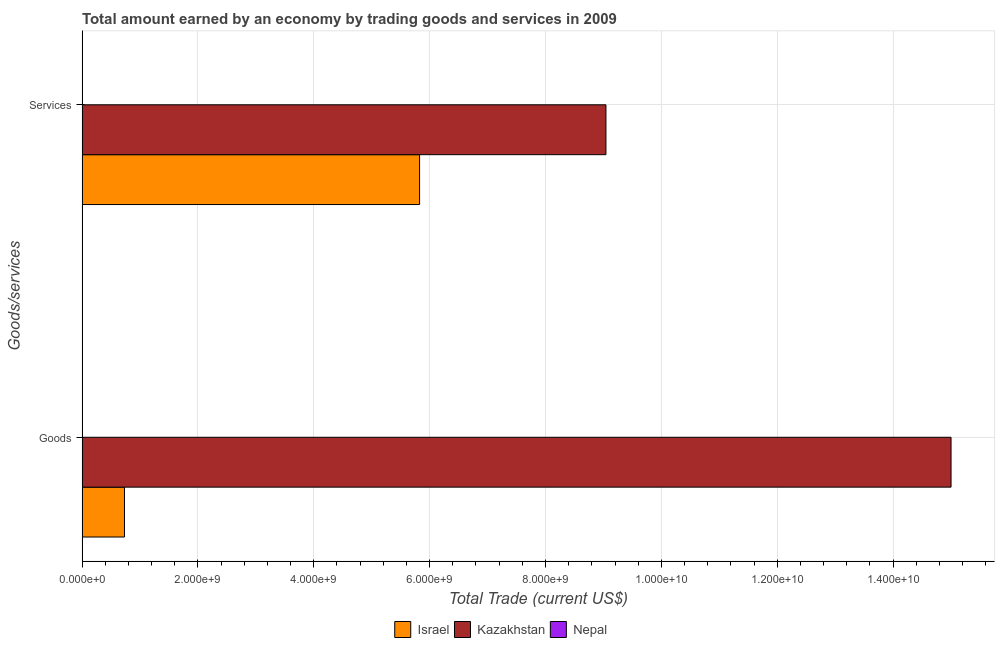How many different coloured bars are there?
Keep it short and to the point. 2. How many groups of bars are there?
Provide a succinct answer. 2. How many bars are there on the 2nd tick from the top?
Your answer should be very brief. 2. How many bars are there on the 2nd tick from the bottom?
Your answer should be compact. 2. What is the label of the 1st group of bars from the top?
Make the answer very short. Services. What is the amount earned by trading goods in Kazakhstan?
Make the answer very short. 1.50e+1. Across all countries, what is the maximum amount earned by trading services?
Provide a succinct answer. 9.04e+09. Across all countries, what is the minimum amount earned by trading services?
Provide a succinct answer. 0. In which country was the amount earned by trading services maximum?
Your answer should be very brief. Kazakhstan. What is the total amount earned by trading services in the graph?
Provide a succinct answer. 1.49e+1. What is the difference between the amount earned by trading services in Kazakhstan and that in Israel?
Keep it short and to the point. 3.22e+09. What is the difference between the amount earned by trading goods in Israel and the amount earned by trading services in Kazakhstan?
Offer a very short reply. -8.31e+09. What is the average amount earned by trading services per country?
Keep it short and to the point. 4.96e+09. What is the difference between the amount earned by trading services and amount earned by trading goods in Kazakhstan?
Provide a succinct answer. -5.96e+09. In how many countries, is the amount earned by trading goods greater than 3600000000 US$?
Ensure brevity in your answer.  1. What is the ratio of the amount earned by trading services in Kazakhstan to that in Israel?
Keep it short and to the point. 1.55. In how many countries, is the amount earned by trading goods greater than the average amount earned by trading goods taken over all countries?
Offer a very short reply. 1. How many countries are there in the graph?
Your answer should be very brief. 3. What is the difference between two consecutive major ticks on the X-axis?
Ensure brevity in your answer.  2.00e+09. Are the values on the major ticks of X-axis written in scientific E-notation?
Offer a terse response. Yes. Does the graph contain any zero values?
Make the answer very short. Yes. Where does the legend appear in the graph?
Keep it short and to the point. Bottom center. How are the legend labels stacked?
Offer a terse response. Horizontal. What is the title of the graph?
Keep it short and to the point. Total amount earned by an economy by trading goods and services in 2009. Does "Czech Republic" appear as one of the legend labels in the graph?
Provide a succinct answer. No. What is the label or title of the X-axis?
Offer a very short reply. Total Trade (current US$). What is the label or title of the Y-axis?
Your answer should be compact. Goods/services. What is the Total Trade (current US$) of Israel in Goods?
Ensure brevity in your answer.  7.33e+08. What is the Total Trade (current US$) in Kazakhstan in Goods?
Ensure brevity in your answer.  1.50e+1. What is the Total Trade (current US$) of Nepal in Goods?
Offer a very short reply. 0. What is the Total Trade (current US$) in Israel in Services?
Your answer should be compact. 5.83e+09. What is the Total Trade (current US$) of Kazakhstan in Services?
Your response must be concise. 9.04e+09. What is the Total Trade (current US$) of Nepal in Services?
Make the answer very short. 0. Across all Goods/services, what is the maximum Total Trade (current US$) of Israel?
Make the answer very short. 5.83e+09. Across all Goods/services, what is the maximum Total Trade (current US$) of Kazakhstan?
Ensure brevity in your answer.  1.50e+1. Across all Goods/services, what is the minimum Total Trade (current US$) in Israel?
Provide a succinct answer. 7.33e+08. Across all Goods/services, what is the minimum Total Trade (current US$) of Kazakhstan?
Provide a short and direct response. 9.04e+09. What is the total Total Trade (current US$) of Israel in the graph?
Offer a terse response. 6.56e+09. What is the total Total Trade (current US$) in Kazakhstan in the graph?
Keep it short and to the point. 2.40e+1. What is the total Total Trade (current US$) in Nepal in the graph?
Make the answer very short. 0. What is the difference between the Total Trade (current US$) of Israel in Goods and that in Services?
Make the answer very short. -5.09e+09. What is the difference between the Total Trade (current US$) of Kazakhstan in Goods and that in Services?
Your answer should be compact. 5.96e+09. What is the difference between the Total Trade (current US$) of Israel in Goods and the Total Trade (current US$) of Kazakhstan in Services?
Make the answer very short. -8.31e+09. What is the average Total Trade (current US$) in Israel per Goods/services?
Keep it short and to the point. 3.28e+09. What is the average Total Trade (current US$) in Kazakhstan per Goods/services?
Give a very brief answer. 1.20e+1. What is the difference between the Total Trade (current US$) in Israel and Total Trade (current US$) in Kazakhstan in Goods?
Your answer should be compact. -1.43e+1. What is the difference between the Total Trade (current US$) in Israel and Total Trade (current US$) in Kazakhstan in Services?
Keep it short and to the point. -3.22e+09. What is the ratio of the Total Trade (current US$) of Israel in Goods to that in Services?
Your answer should be very brief. 0.13. What is the ratio of the Total Trade (current US$) of Kazakhstan in Goods to that in Services?
Your answer should be very brief. 1.66. What is the difference between the highest and the second highest Total Trade (current US$) of Israel?
Ensure brevity in your answer.  5.09e+09. What is the difference between the highest and the second highest Total Trade (current US$) in Kazakhstan?
Keep it short and to the point. 5.96e+09. What is the difference between the highest and the lowest Total Trade (current US$) in Israel?
Ensure brevity in your answer.  5.09e+09. What is the difference between the highest and the lowest Total Trade (current US$) of Kazakhstan?
Your answer should be very brief. 5.96e+09. 